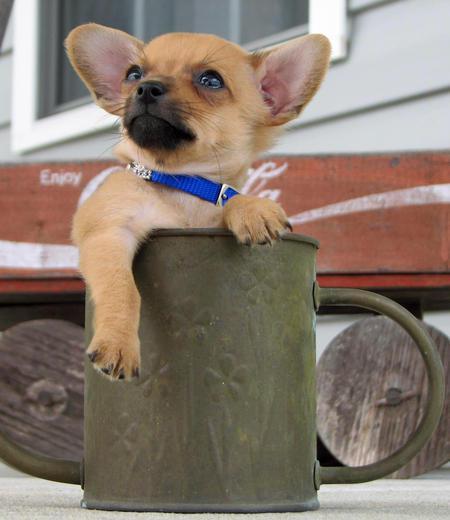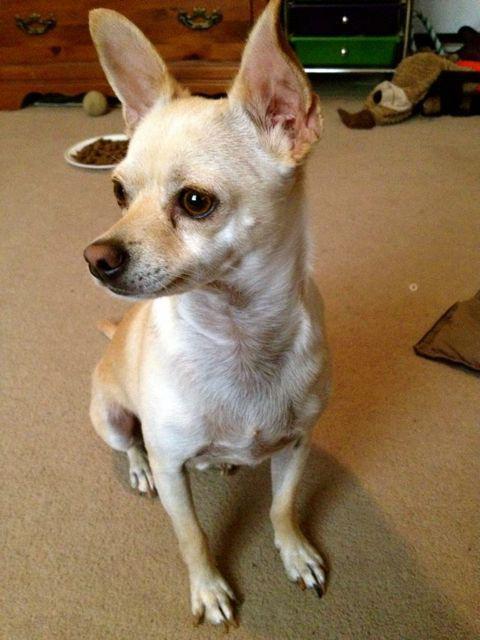The first image is the image on the left, the second image is the image on the right. For the images shown, is this caption "Each image contains exactly one dog, and the right image features a black-and-white dog wearing a red collar." true? Answer yes or no. No. The first image is the image on the left, the second image is the image on the right. Analyze the images presented: Is the assertion "The right image contains a black and white chihuahua that is wearing a red collar." valid? Answer yes or no. No. 